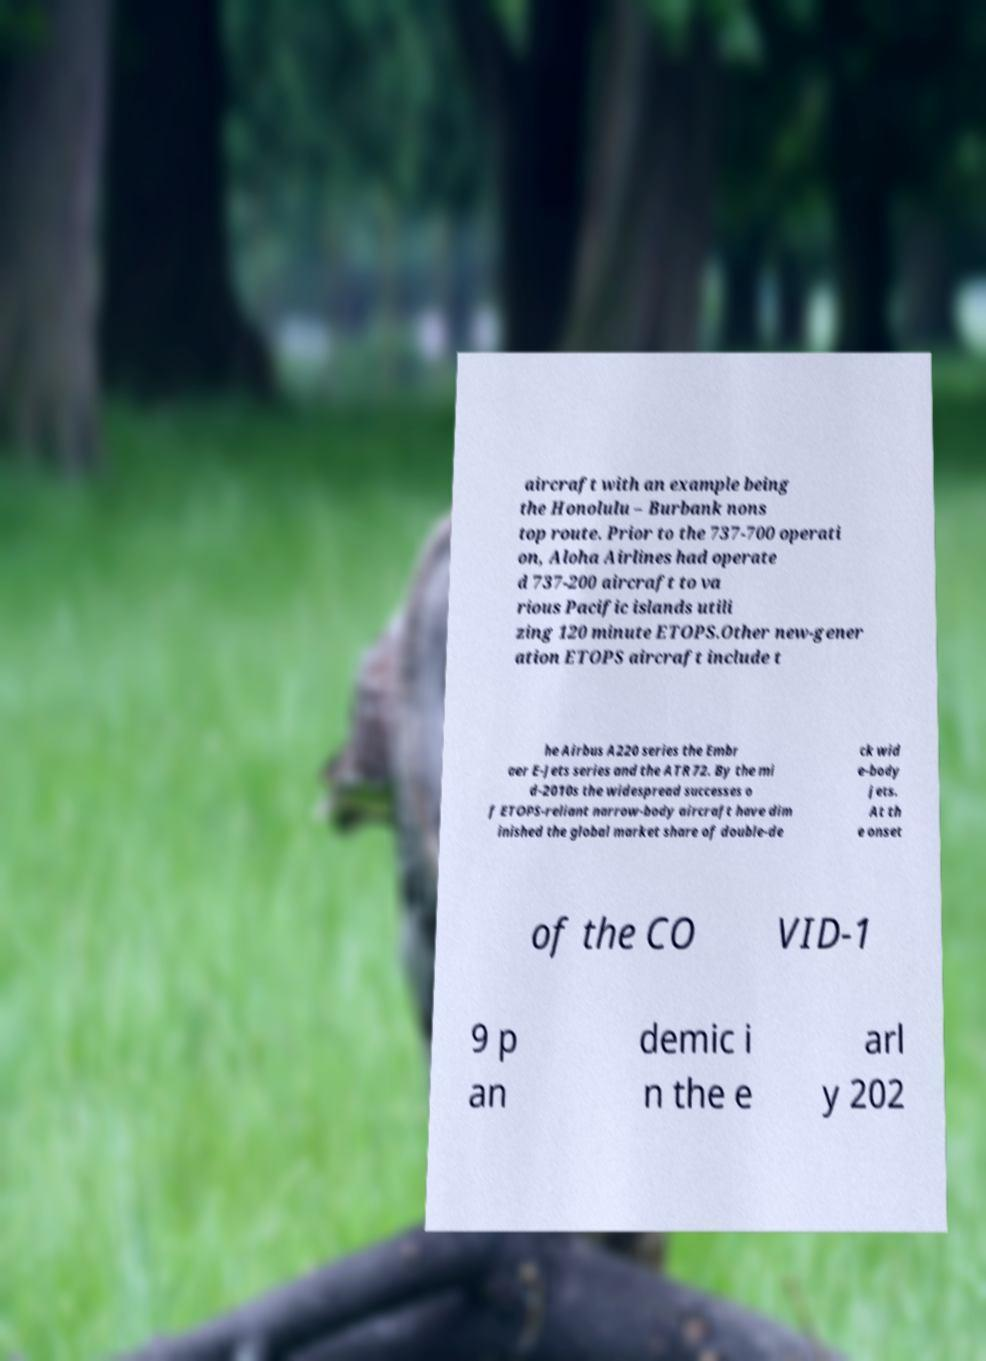Can you accurately transcribe the text from the provided image for me? aircraft with an example being the Honolulu – Burbank nons top route. Prior to the 737-700 operati on, Aloha Airlines had operate d 737-200 aircraft to va rious Pacific islands utili zing 120 minute ETOPS.Other new-gener ation ETOPS aircraft include t he Airbus A220 series the Embr aer E-Jets series and the ATR 72. By the mi d-2010s the widespread successes o f ETOPS-reliant narrow-body aircraft have dim inished the global market share of double-de ck wid e-body jets. At th e onset of the CO VID-1 9 p an demic i n the e arl y 202 